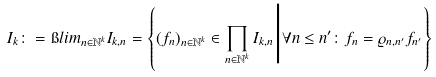Convert formula to latex. <formula><loc_0><loc_0><loc_500><loc_500>I _ { k } \colon = \i l i m _ { n \in \mathbb { N } ^ { k } } I _ { k , n } = \left \{ ( f _ { n } ) _ { n \in \mathbb { N } ^ { k } } \in \prod _ { n \in \mathbb { N } ^ { k } } I _ { k , n } \Big | \forall n \leq n ^ { \prime } \colon f _ { n } = \varrho _ { n , n ^ { \prime } } f _ { n ^ { \prime } } \right \}</formula> 